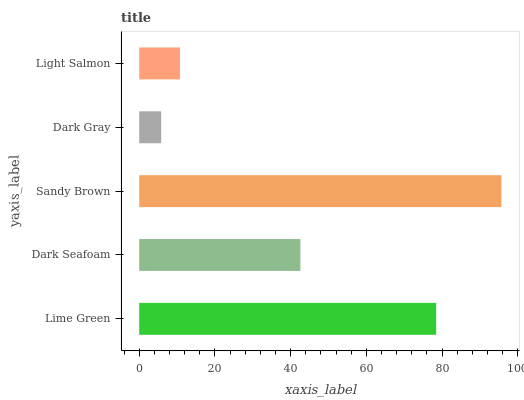Is Dark Gray the minimum?
Answer yes or no. Yes. Is Sandy Brown the maximum?
Answer yes or no. Yes. Is Dark Seafoam the minimum?
Answer yes or no. No. Is Dark Seafoam the maximum?
Answer yes or no. No. Is Lime Green greater than Dark Seafoam?
Answer yes or no. Yes. Is Dark Seafoam less than Lime Green?
Answer yes or no. Yes. Is Dark Seafoam greater than Lime Green?
Answer yes or no. No. Is Lime Green less than Dark Seafoam?
Answer yes or no. No. Is Dark Seafoam the high median?
Answer yes or no. Yes. Is Dark Seafoam the low median?
Answer yes or no. Yes. Is Dark Gray the high median?
Answer yes or no. No. Is Lime Green the low median?
Answer yes or no. No. 